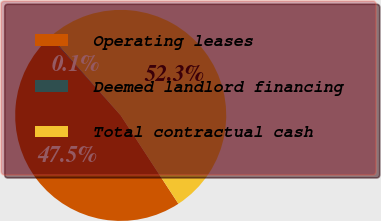Convert chart. <chart><loc_0><loc_0><loc_500><loc_500><pie_chart><fcel>Operating leases<fcel>Deemed landlord financing<fcel>Total contractual cash<nl><fcel>47.55%<fcel>0.14%<fcel>52.31%<nl></chart> 